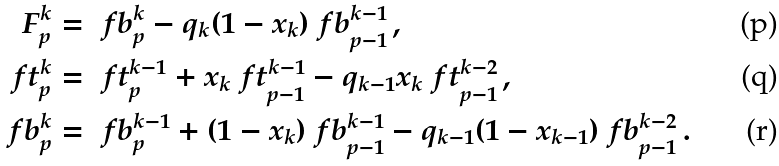Convert formula to latex. <formula><loc_0><loc_0><loc_500><loc_500>F _ { p } ^ { k } & = \ f b _ { p } ^ { k } - q _ { k } ( 1 - x _ { k } ) \ f b _ { p - 1 } ^ { k - 1 } \, , \\ \ f t _ { p } ^ { k } & = \ f t _ { p } ^ { k - 1 } + x _ { k } \ f t _ { p - 1 } ^ { k - 1 } - q _ { k - 1 } x _ { k } \ f t _ { p - 1 } ^ { k - 2 } \, , \\ \ f b _ { p } ^ { k } & = \ f b _ { p } ^ { k - 1 } + ( 1 - x _ { k } ) \ f b _ { p - 1 } ^ { k - 1 } - q _ { k - 1 } ( 1 - x _ { k - 1 } ) \ f b _ { p - 1 } ^ { k - 2 } \, .</formula> 